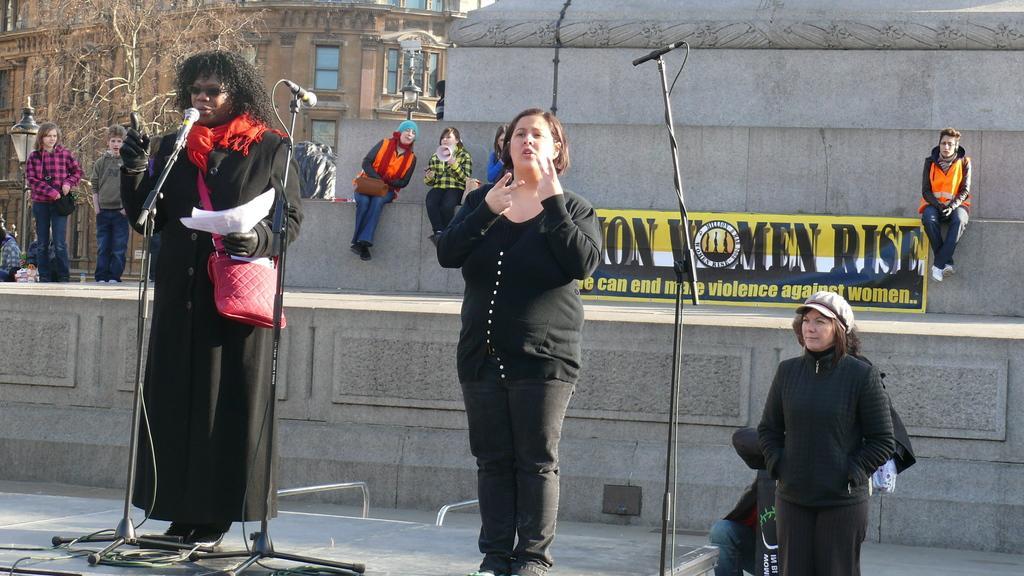Could you give a brief overview of what you see in this image? In this image I see 3 women who are standing and I see that this woman is holding papers in her hands and I see that she is wearing a bag and I see 3 tripods and I see mics on it. In the background I see few more people and I see something is written over here and I see the building and the trees. 